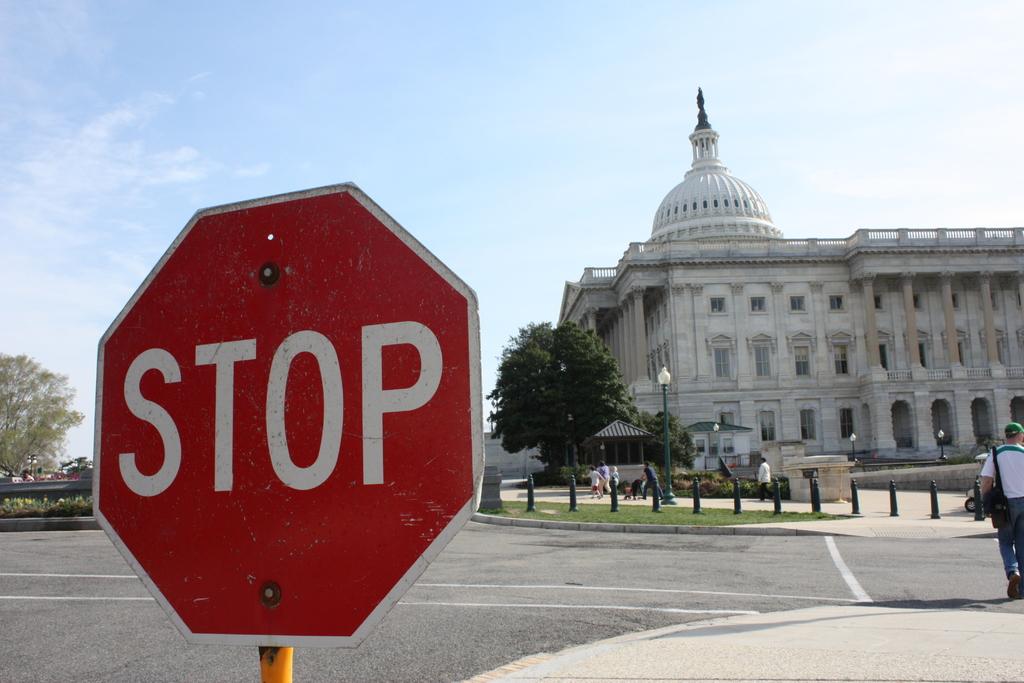What type of sign is this?
Keep it short and to the point. Stop. 